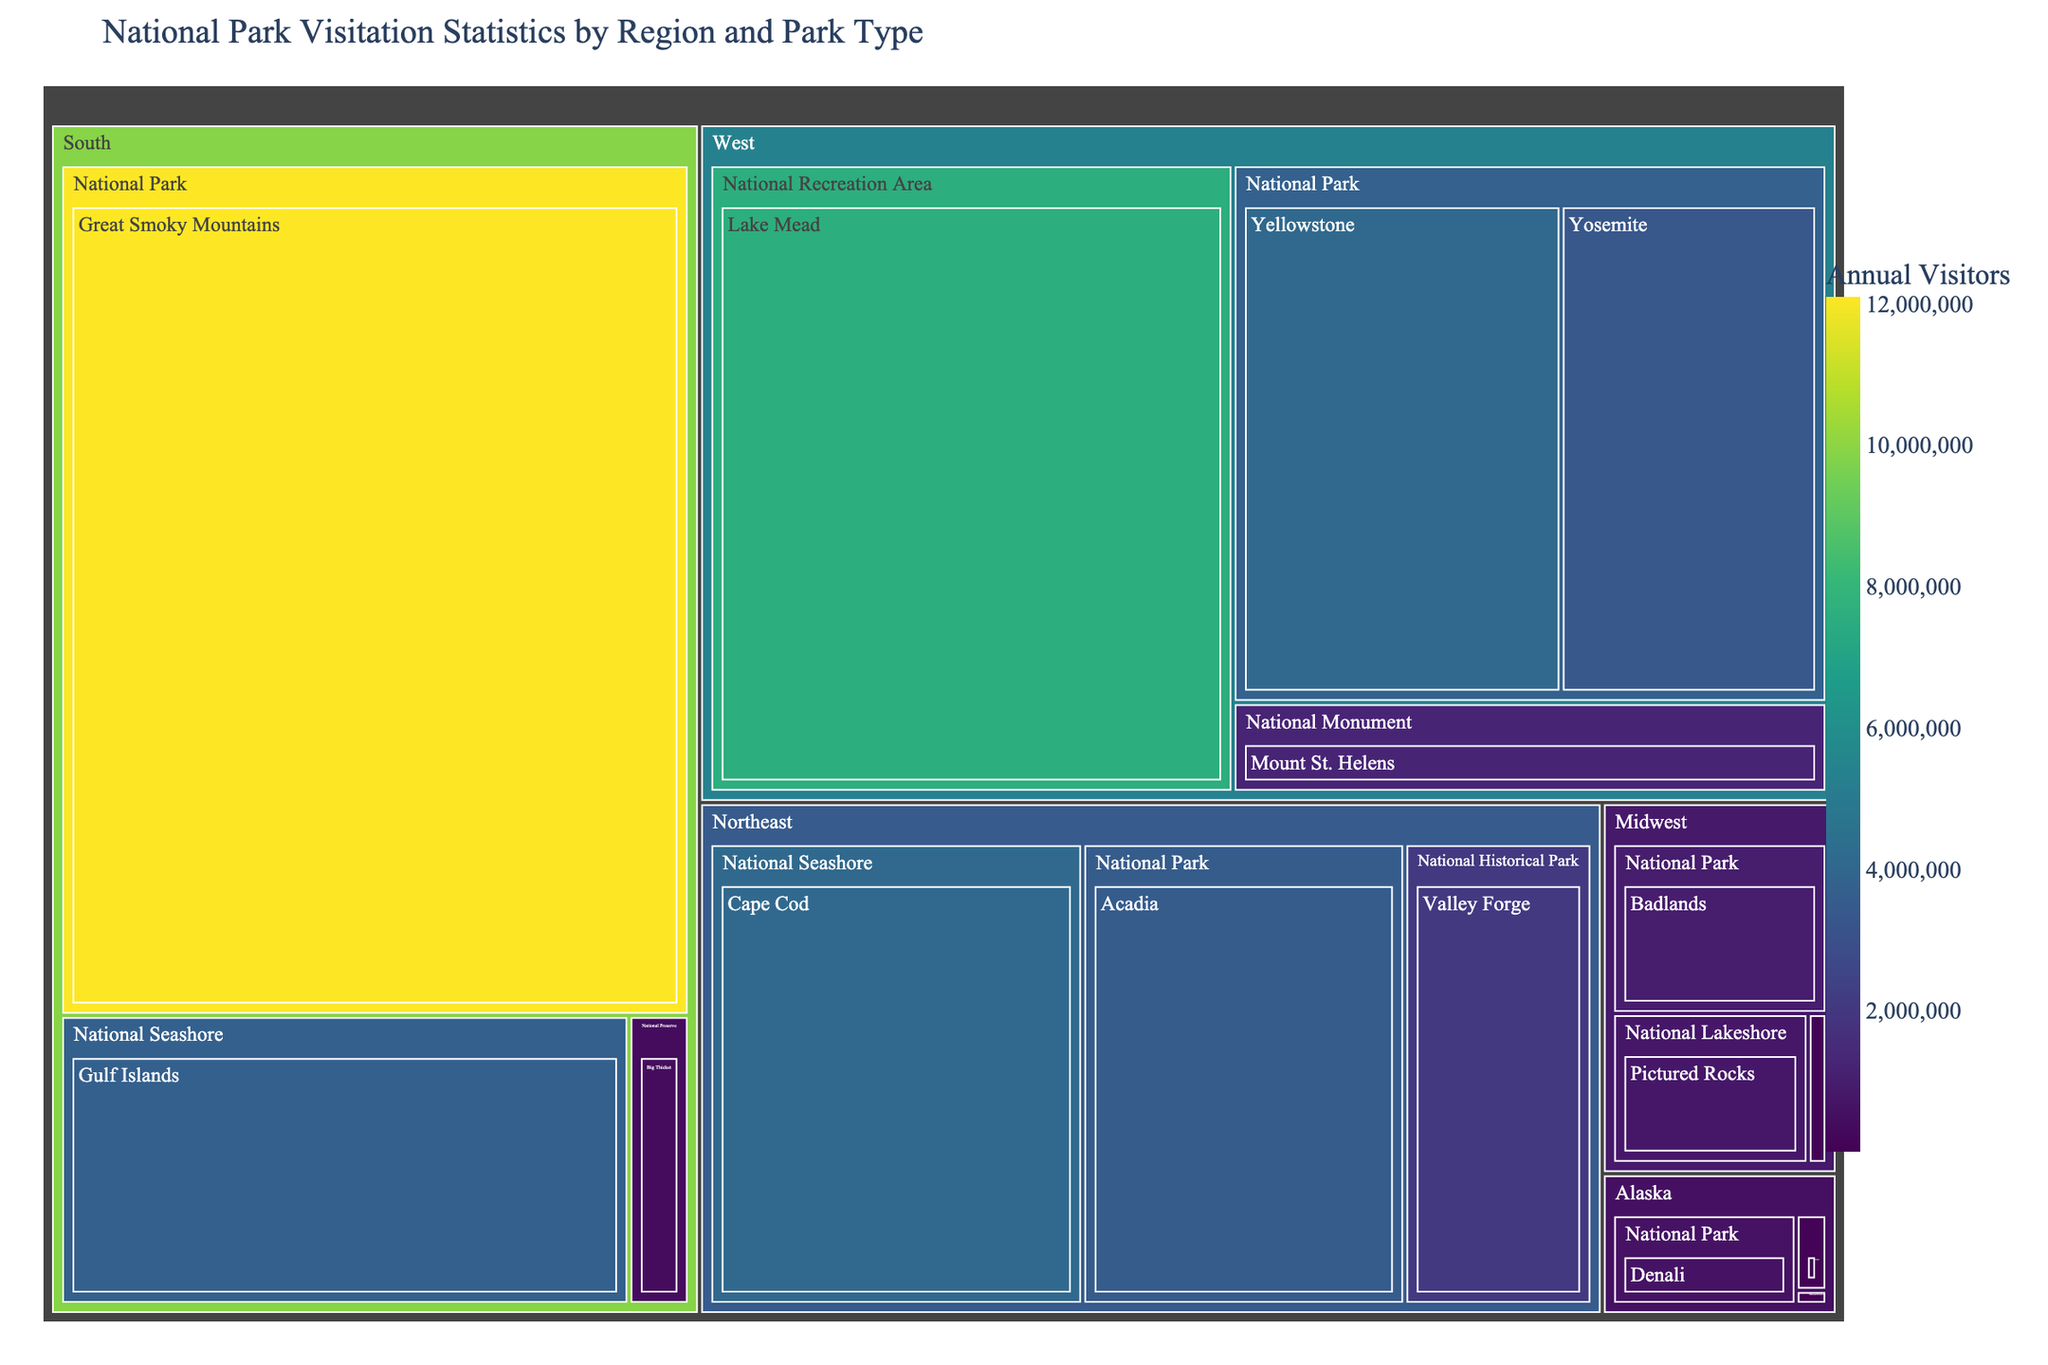What is the title of the treemap? The title is usually displayed at the top of the treemap to provide context about what the plot is representing. In this case, the title of the treemap is "National Park Visitation Statistics by Region and Park Type".
Answer: National Park Visitation Statistics by Region and Park Type Which National Park has the highest annual visitors? By looking at the sizes of the tiles representing different national parks, the one with the largest area signifies the highest number of annual visitors. The Great Smoky Mountains National Park has the largest tile.
Answer: Great Smoky Mountains What is the total number of visitors for National Monuments in the West? Locate all the tiles under the 'National Monument' category within the 'West' region, then sum up their values. This includes Mount St. Helens with 1,229,025 visitors.
Answer: 1,229,025 Which region has the smallest representation in terms of park variety? Count the number of distinct park types within each region by observing the labels on the treemap. Alaska has the fewest park types, which are National Park, National Preserve, and National Monument.
Answer: Alaska Compare the annual visitors between the National Parks in the Midwest and the Northeast. Which has more? Calculate the sum of the visitors for the National Parks in the Midwest (Badlands: 970,998) and the Northeast (Acadia: 3,537,575). Acadia in the Northeast has more visitors.
Answer: Northeast What percentage of total visitors does Yellowstone National Park represent? Divide the number of visitors to Yellowstone (4,086,890) by the sum of visitors for all parks, then multiply by 100. Sum up all the visitors: 40,952,513, then (4,086,890 / 40,952,513) * 100 ≈ 9.98%.
Answer: 9.98% How many park types are represented in the South region? Identify and count the unique types of parks in the South region by examining the treemap structure. The South has National Park, National Seashore, and National Preserve.
Answer: 3 Which park type has the most visitors in the Northeast? Observe the tiles under the Northeast region and compare their sizes. Cape Cod National Seashore has the tile with the largest area.
Answer: National Seashore (Cape Cod) Rank the National Parks in Alaska by their visitors. Check the sizes of tiles representing National Parks in Alaska and list them in descending order of visitors. Denali: 594,660, Katmai: 84,167, Noatak: 15,740.
Answer: Denali, Katmai, Noatak How does the size of the tile for Yosemite National Park compare to that for Big Thicket National Preserve? Observe the relative sizes of the tiles for Yosemite National Park and Big Thicket National Preserve. Yosemite's tile is significantly larger than Big Thicket's tile, indicating higher visitation.
Answer: Yosemite is larger 